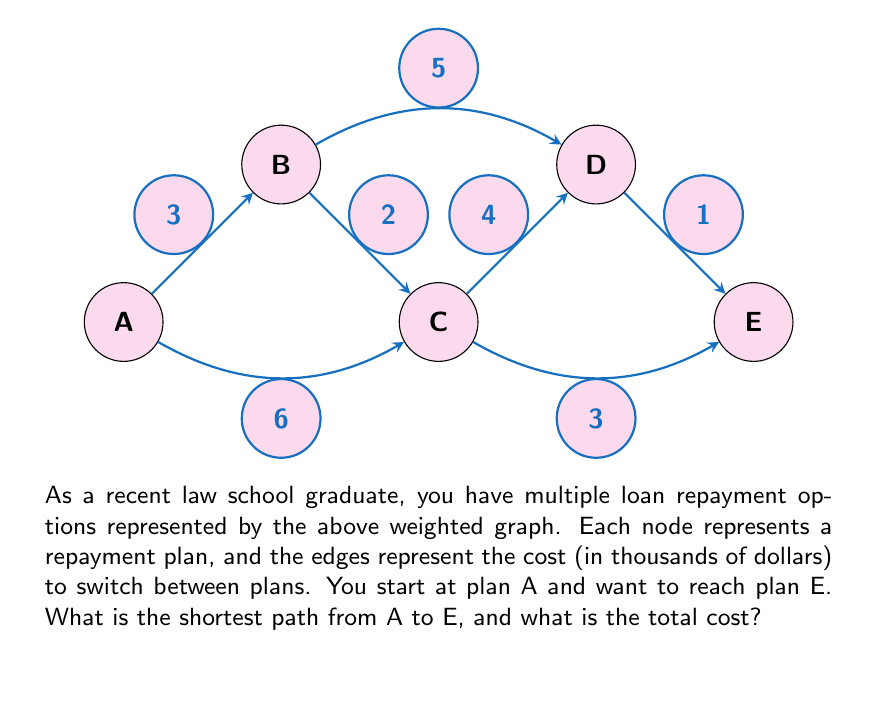Give your solution to this math problem. To solve this problem, we can use Dijkstra's algorithm to find the shortest path from A to E. Let's go through the steps:

1) Initialize:
   - Distance to A: 0
   - Distance to all other nodes: $\infty$
   - Unvisited set: {A, B, C, D, E}

2) Start from A:
   - Update distances: B(3), C(6)
   - Mark A as visited
   - Unvisited set: {B, C, D, E}

3) Choose B (shortest distance from A):
   - Update distances: C = min(6, 3+2) = 5, D(3+5=8)
   - Mark B as visited
   - Unvisited set: {C, D, E}

4) Choose C (shortest distance from A):
   - Update distances: D = min(8, 5+4) = 8, E(5+3=8)
   - Mark C as visited
   - Unvisited set: {D, E}

5) Choose E (shortest distance from A):
   - No updates needed
   - Mark E as visited
   - Algorithm terminates as we've reached our target

The shortest path is A -> B -> C -> E with a total cost of $3 + $2 + $3 = $8 thousand.
Answer: A -> B -> C -> E, $8,000 